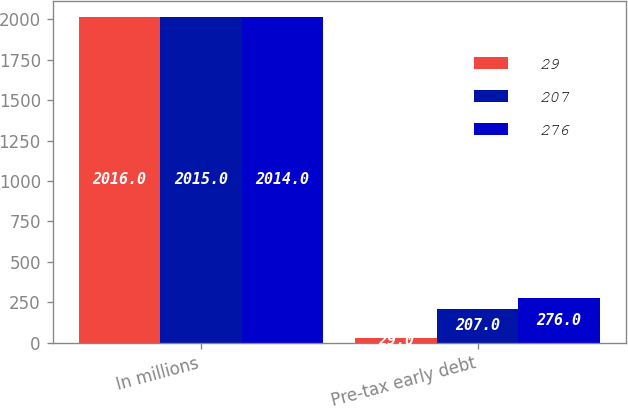Convert chart. <chart><loc_0><loc_0><loc_500><loc_500><stacked_bar_chart><ecel><fcel>In millions<fcel>Pre-tax early debt<nl><fcel>29<fcel>2016<fcel>29<nl><fcel>207<fcel>2015<fcel>207<nl><fcel>276<fcel>2014<fcel>276<nl></chart> 